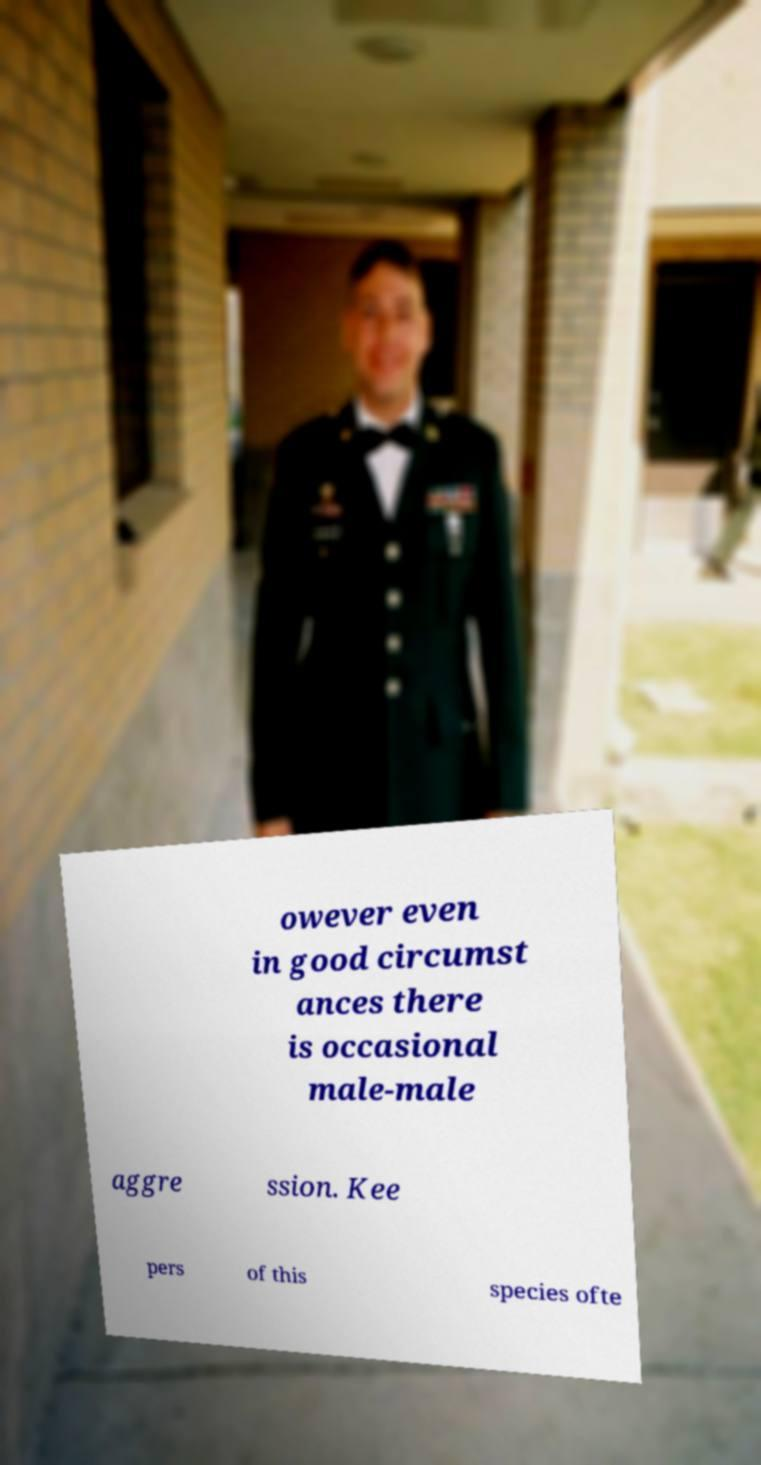Please identify and transcribe the text found in this image. owever even in good circumst ances there is occasional male-male aggre ssion. Kee pers of this species ofte 